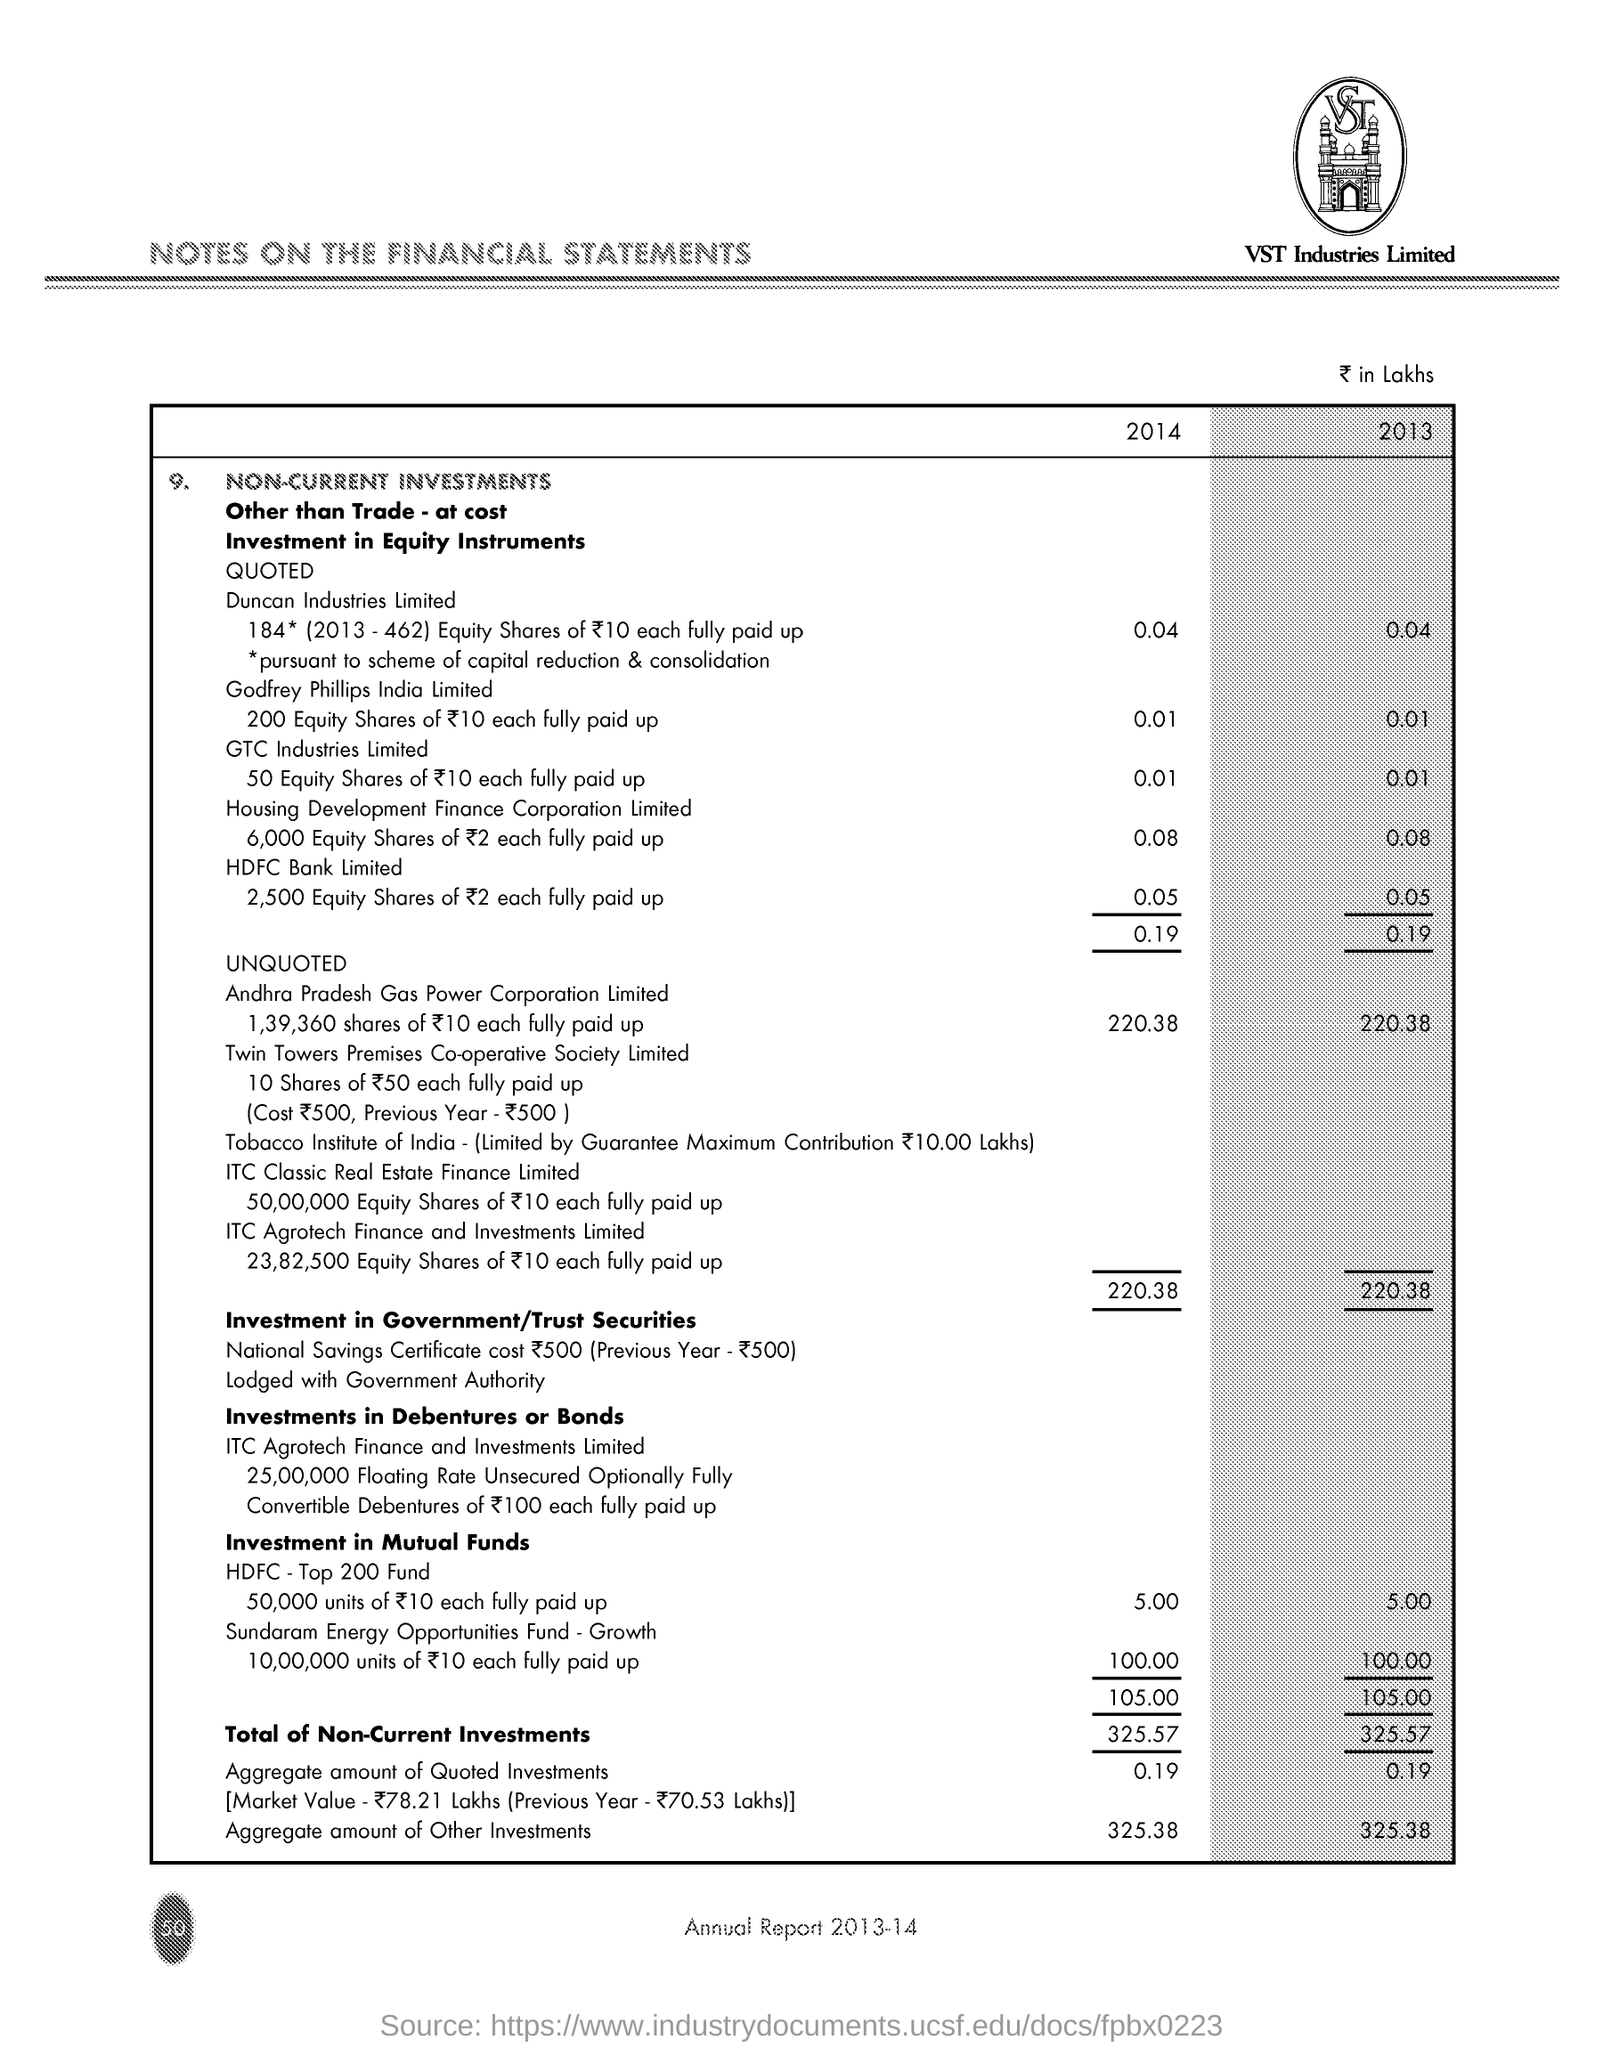Specify some key components in this picture. In 2014, the aggregate amount of other investments was 325.38. The text below the image reads 'VST Industries Limited.' The total amount of quoted investments in 2013 was 0.19. The title of the document is "Notes on the Financial Statements. 